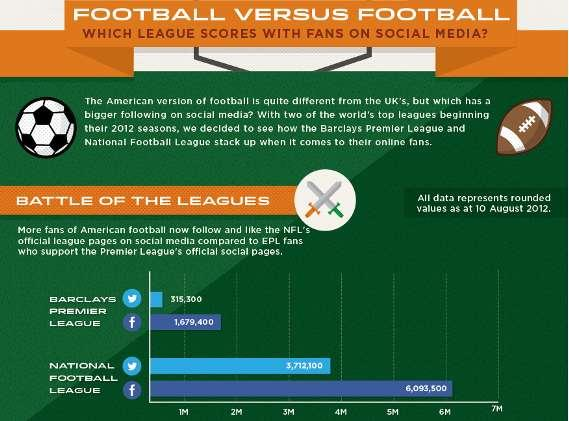Highlight a few significant elements in this photo. As of August 10th, 2012, the number of Twitter followers of the National Football League (NFL) was 3,712,100. As of August 10, 2012, the number of Facebook followers of the English Premier League (EPL) was 1,679,400. 